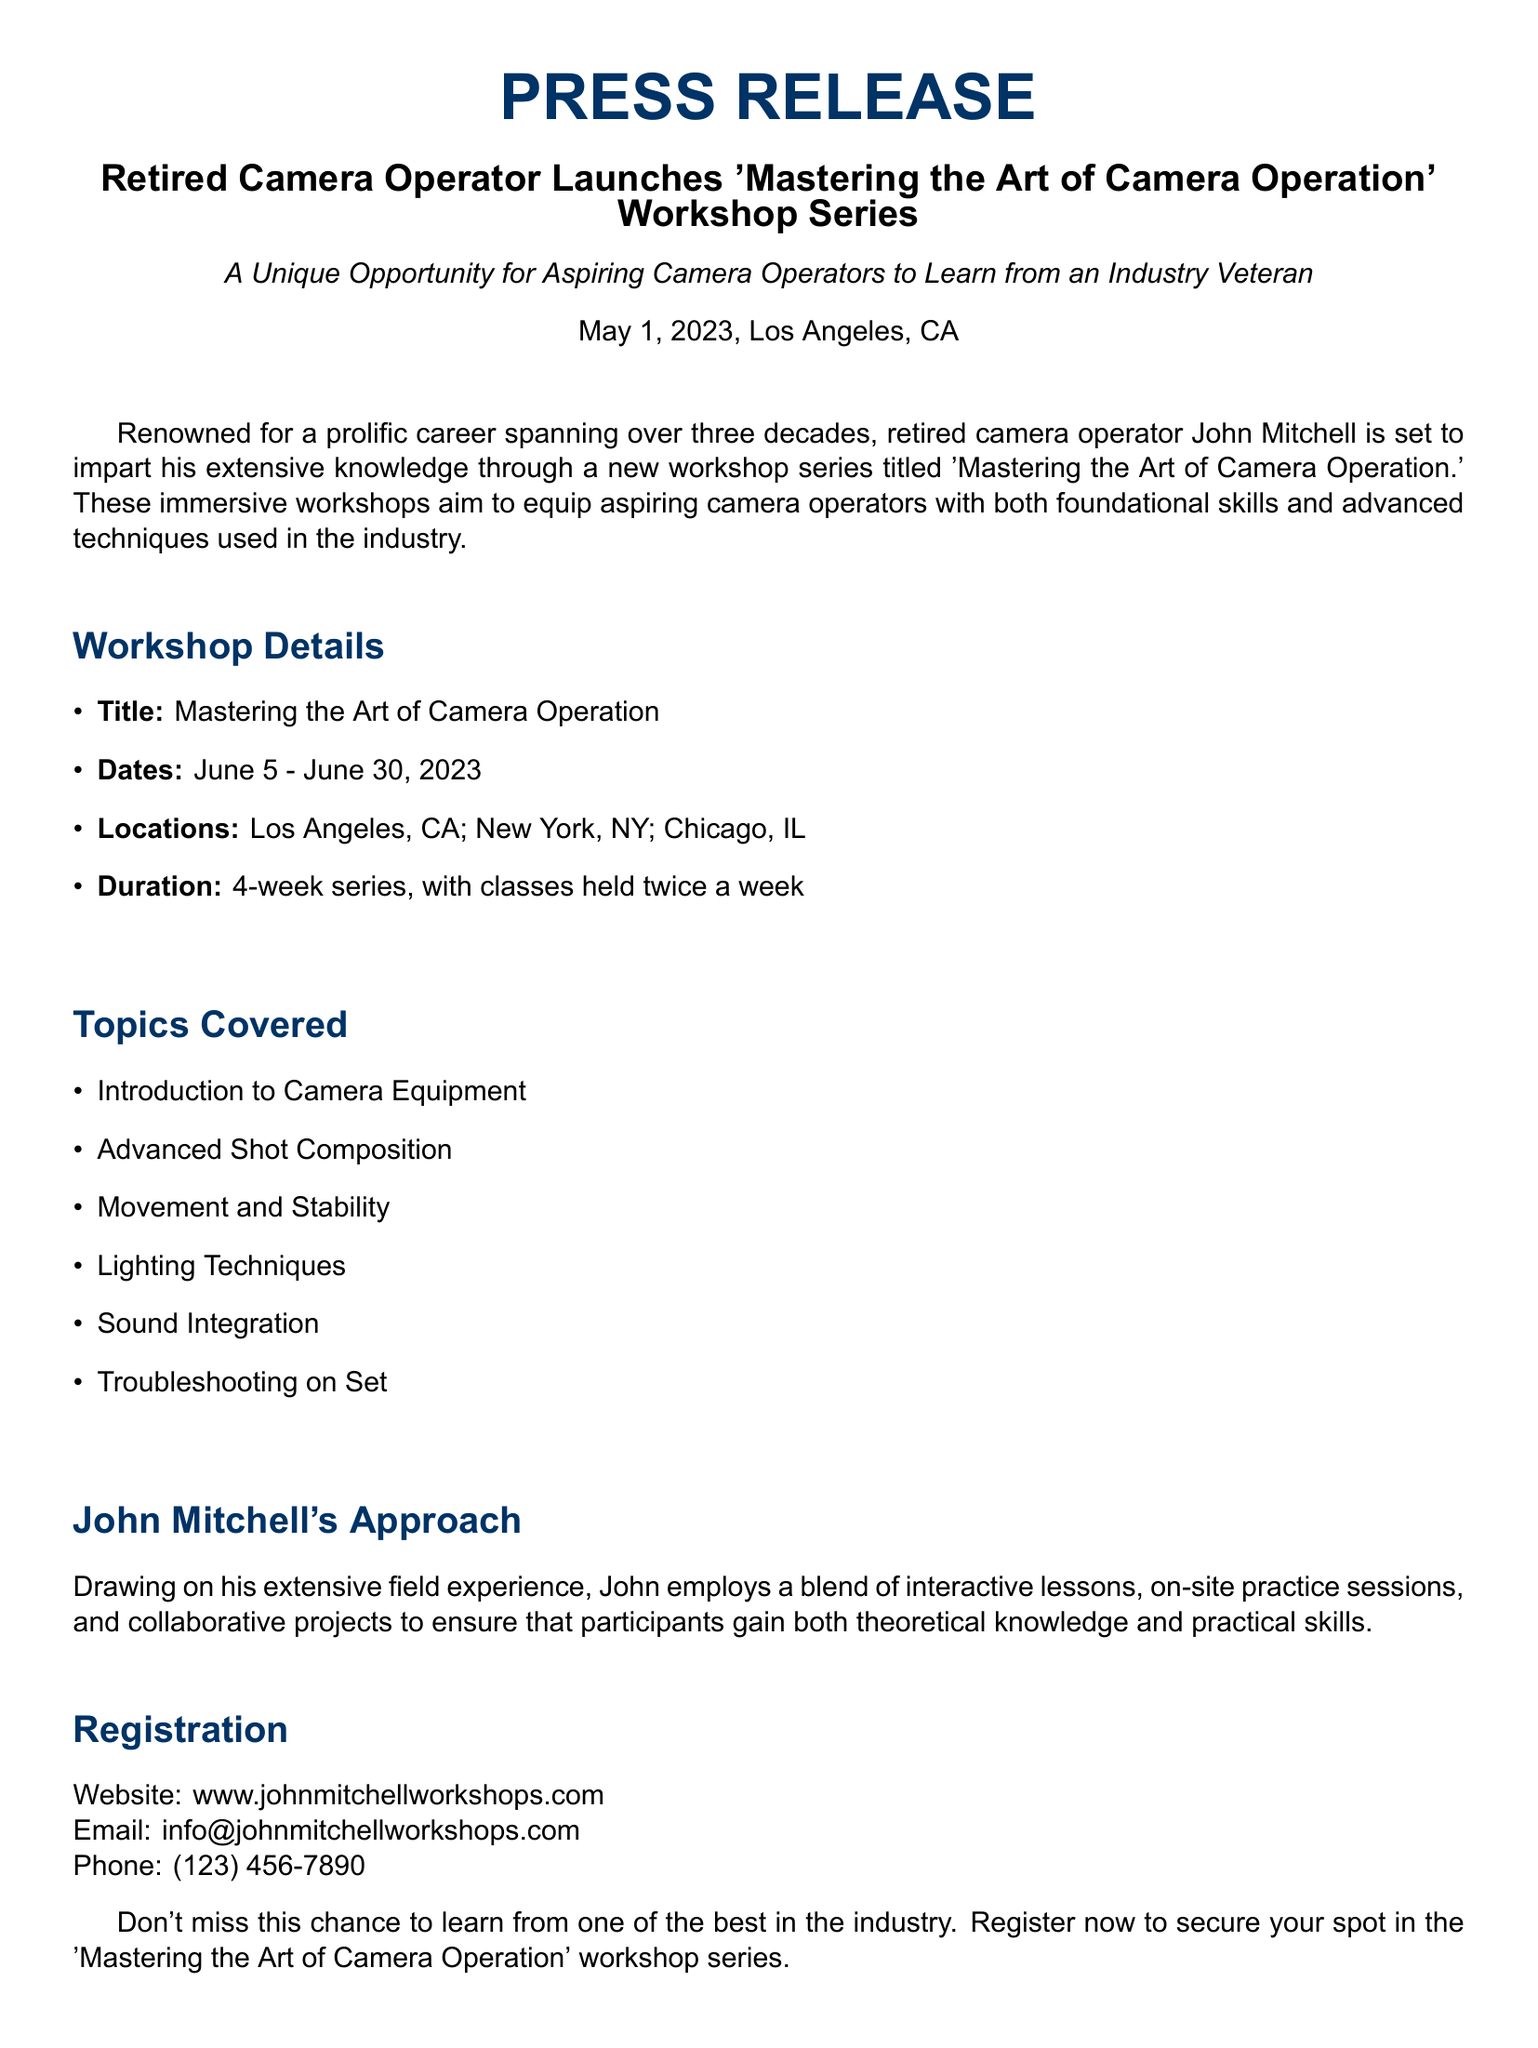What is the title of the workshop series? The title of the workshop series is mentioned in the headline of the press release.
Answer: Mastering the Art of Camera Operation Who is conducting the workshop series? The press release highlights the name of the person conducting the workshops.
Answer: John Mitchell Where will the workshops take place? The locations are clearly listed in the workshop details section.
Answer: Los Angeles, CA; New York, NY; Chicago, IL How many weeks does the workshop series last? The duration of the workshop series is specified in the document.
Answer: 4-week series What is one of the topics covered in the workshops? The topics covered are listed in the document, one can be highlighted as an example.
Answer: Introduction to Camera Equipment How often will the classes be held? The frequency of the classes is mentioned in the workshop details.
Answer: Twice a week What approach does John Mitchell use for teaching? The teaching approach is described in a dedicated section of the press release.
Answer: Interactive lessons and on-site practice sessions What is the registration website? The registration details provide a specific website for signing up.
Answer: www.johnmitchellworkshops.com When do the workshops start? The starting date is clearly stated in the press release.
Answer: June 5, 2023 